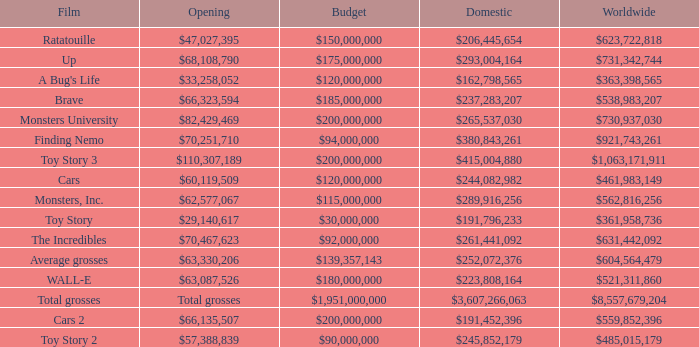WHAT IS THE BUDGET FOR THE INCREDIBLES? $92,000,000. 